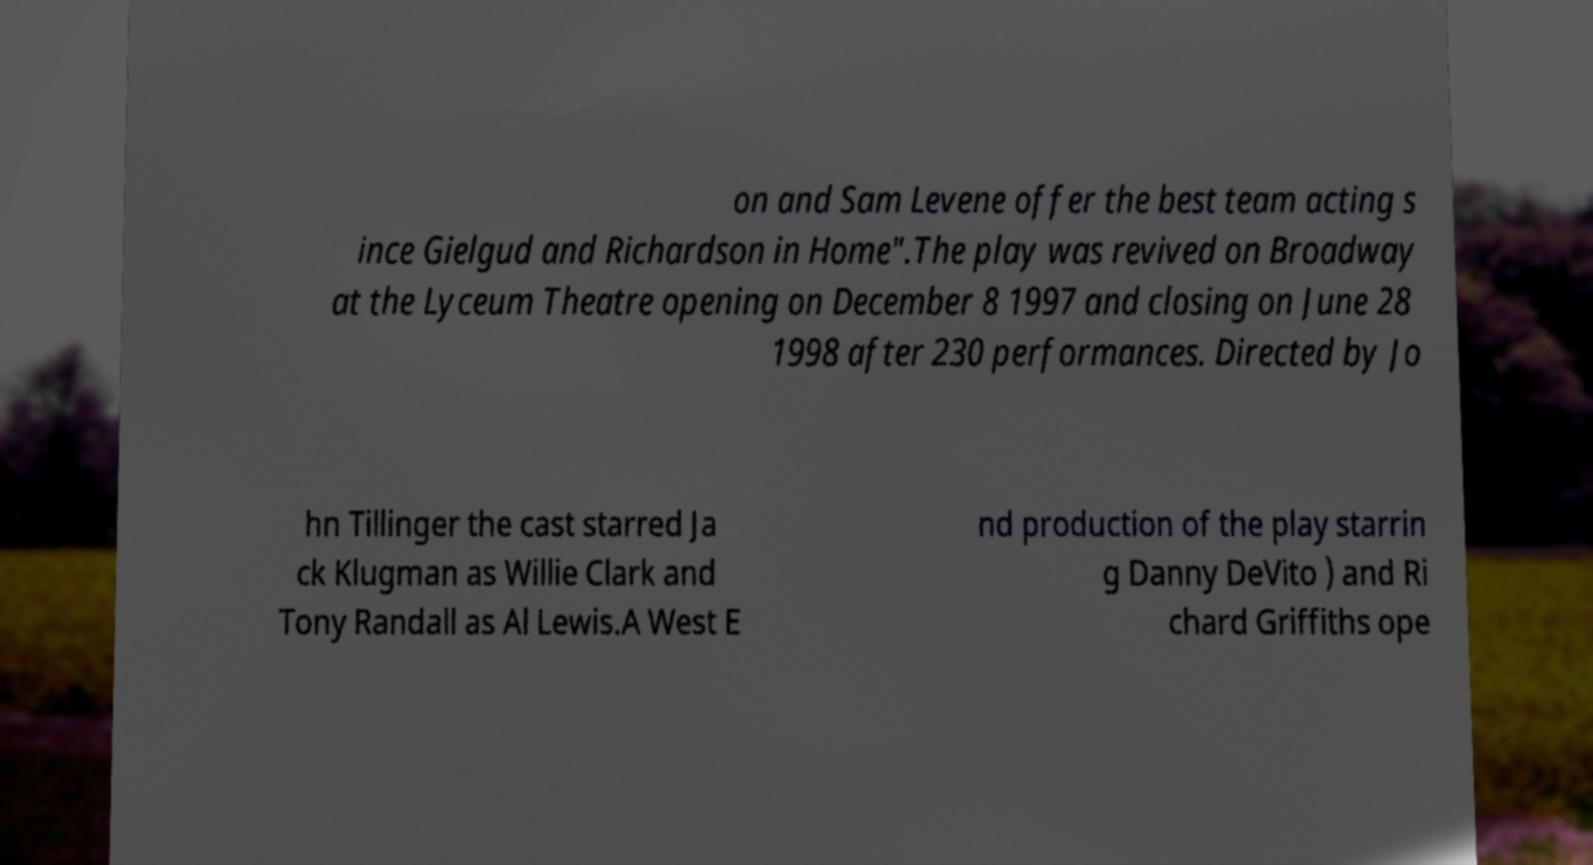Could you assist in decoding the text presented in this image and type it out clearly? on and Sam Levene offer the best team acting s ince Gielgud and Richardson in Home".The play was revived on Broadway at the Lyceum Theatre opening on December 8 1997 and closing on June 28 1998 after 230 performances. Directed by Jo hn Tillinger the cast starred Ja ck Klugman as Willie Clark and Tony Randall as Al Lewis.A West E nd production of the play starrin g Danny DeVito ) and Ri chard Griffiths ope 